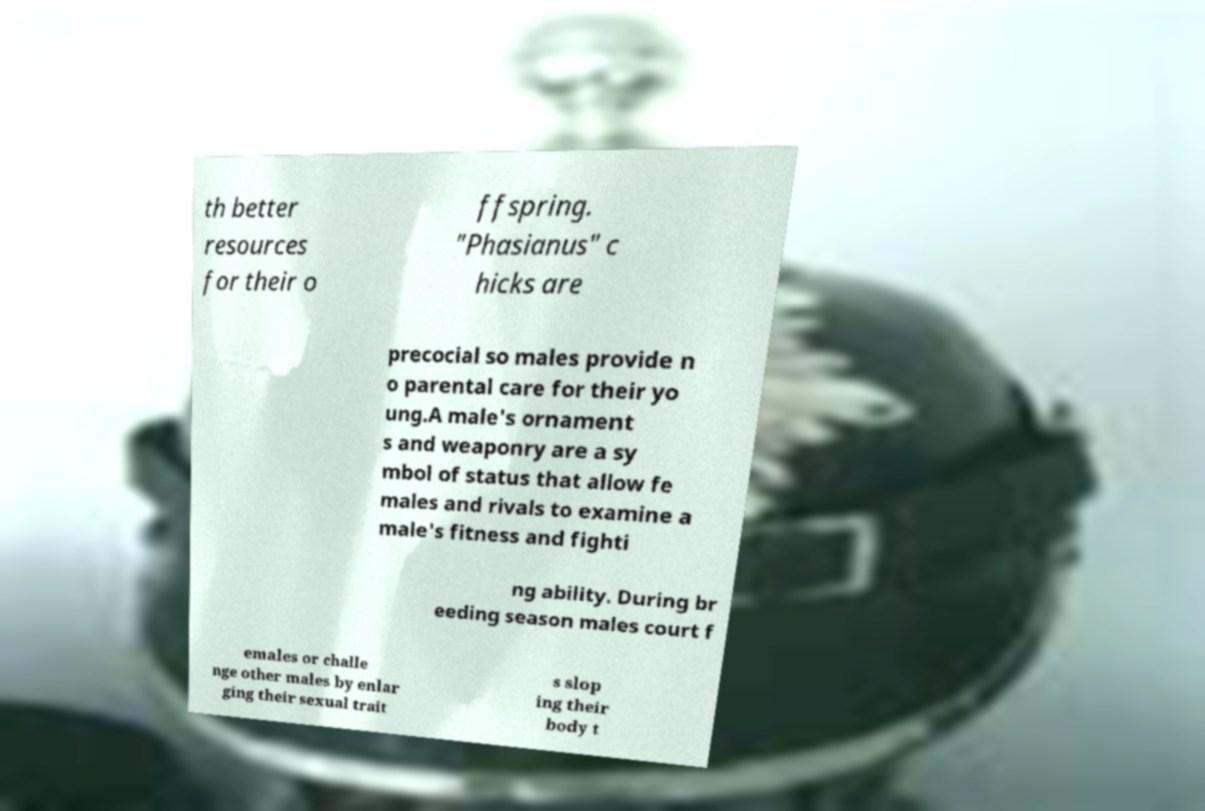There's text embedded in this image that I need extracted. Can you transcribe it verbatim? th better resources for their o ffspring. "Phasianus" c hicks are precocial so males provide n o parental care for their yo ung.A male's ornament s and weaponry are a sy mbol of status that allow fe males and rivals to examine a male's fitness and fighti ng ability. During br eeding season males court f emales or challe nge other males by enlar ging their sexual trait s slop ing their body t 